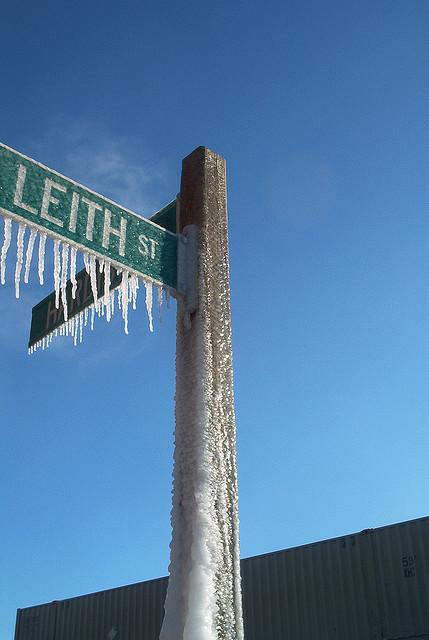What color are the letters on the street sign?
Keep it brief. White. What is the name of the street?
Keep it brief. Leith. What is hanging off the Street sign?
Give a very brief answer. Icicles. 